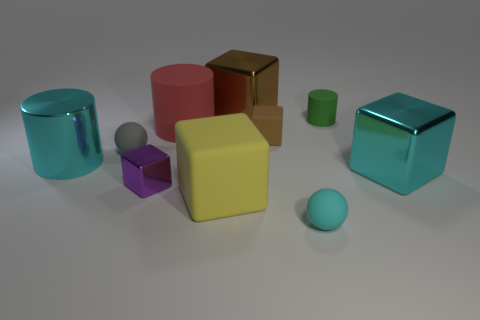Subtract all tiny metal blocks. How many blocks are left? 4 Subtract all cyan blocks. How many blocks are left? 4 Subtract all yellow cylinders. Subtract all purple spheres. How many cylinders are left? 3 Subtract all spheres. How many objects are left? 8 Add 8 big gray matte blocks. How many big gray matte blocks exist? 8 Subtract 0 purple cylinders. How many objects are left? 10 Subtract all cyan metallic objects. Subtract all tiny cyan rubber spheres. How many objects are left? 7 Add 5 small cylinders. How many small cylinders are left? 6 